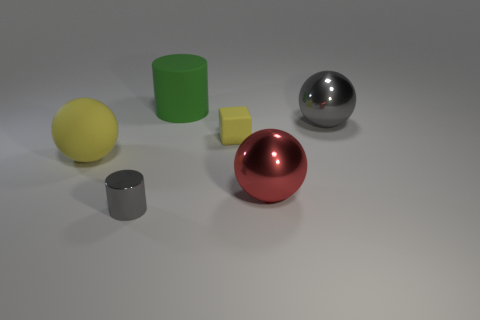There is a big thing to the right of the red thing; is it the same color as the cylinder that is behind the small metal object?
Offer a very short reply. No. The tiny cylinder is what color?
Offer a very short reply. Gray. Is there any other thing that has the same color as the large matte cylinder?
Your answer should be very brief. No. What color is the ball that is behind the red metallic thing and right of the large matte cylinder?
Your answer should be very brief. Gray. Is the size of the gray thing in front of the red metal object the same as the big matte cylinder?
Keep it short and to the point. No. Are there more big yellow rubber balls that are behind the small gray metallic cylinder than big shiny spheres?
Your answer should be very brief. No. Is the tiny shiny thing the same shape as the green thing?
Keep it short and to the point. Yes. What is the size of the red sphere?
Ensure brevity in your answer.  Large. Is the number of big spheres that are to the left of the tiny metallic cylinder greater than the number of large green rubber objects that are to the right of the tiny block?
Your answer should be very brief. Yes. Are there any yellow things on the right side of the green cylinder?
Provide a short and direct response. Yes. 